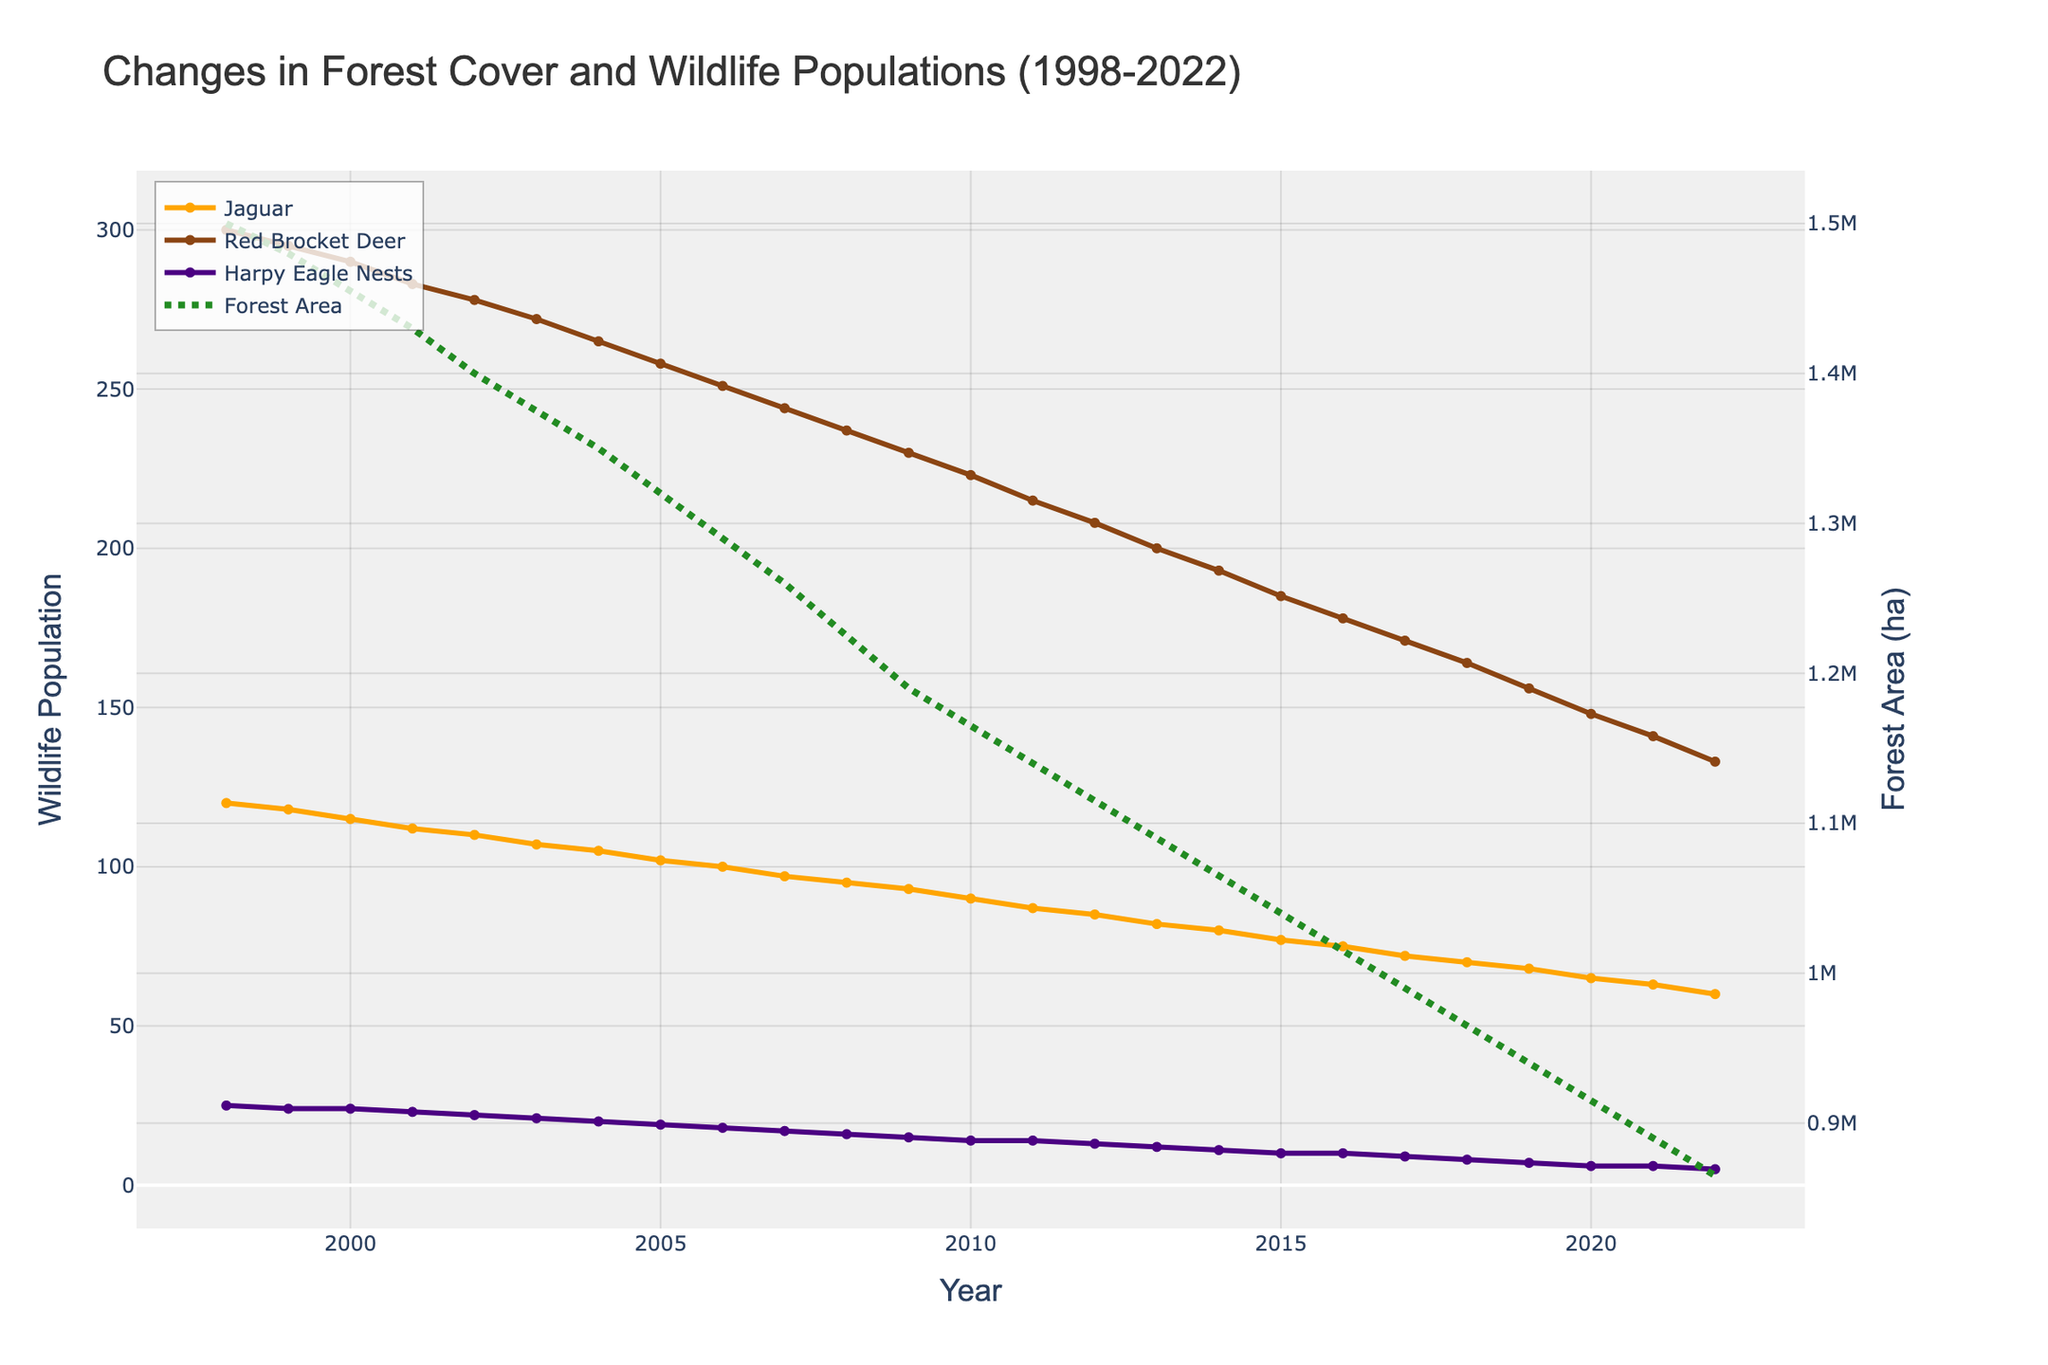What is the title of the figure? The title of the figure is typically placed at the top of the chart and is meant to describe the content of the visual representation. The title in this case is prominently displayed and reads "Changes in Forest Cover and Wildlife Populations (1998-2022)."
Answer: Changes in Forest Cover and Wildlife Populations (1998-2022) How has the Jaguar population changed over the 25-year period? To answer this, you need to look at the line representing Jaguar Population on the plot. The line starts near 120 in 1998 and shows a decline over time, ending at 60 in 2022. This indicates the population has halved over this period.
Answer: Decreased from 120 to 60 Which wildlife population saw the sharpest decline? By examining the slopes of the lines representing each wildlife population, the Jaguar population line shows the steepest slope indicating the sharpest decline when compared to Red Brocket Deer and Harpy Eagle Nests.
Answer: Jaguar Population What was the forest area in hectares in the year 2010? To answer this, find the point on the Forest Area line (dotted line) corresponding to the year 2010. The value at this point will be read off the right y-axis. The forest area in 2010 is approximately 1,165,000 hectares.
Answer: 1,165,000 hectares Between which two years did the Jaguar population experience the largest decline? To determine this, examine the slopes of the Jaguar Population line segments between each pair of consecutive years. The largest decline in Jaguar population appears between 1998 and 1999.
Answer: Between 1998 and 1999 Does the Harpy Eagle Nest Sightings appear to have a direct relationship with forest area? By visually comparing the trend of Harpy Eagle Nest Sightings with the trend of Forest Area over the years, it is noticeable that as the forest area decreases, Harpy Eagle Nest Sightings also decrease. This suggests a potential direct relationship.
Answer: Yes, it has a direct relationship How has the Red Brocket Deer population changed from the year 2000 to 2010? Locate both years on the x-axis and look at the Red Brocket Deer line values. In 2000, the population was 290, and in 2010, it was 223, hence the population decreased by 67.
Answer: Decreased by 67 (from 290 to 223) What is the trend in forest area over the 25 years? By following the dotted Forest Area line across the x-axis from 1998 to 2022, it is clear that the forest area has been consistently declining.
Answer: Consistently declining Which year saw equal values for Jaguar Population and Red Brocket Deer Population on the left y-axis scale? Carefully examine the plot to see if, at any point, the lines for Jaguar Population and Red Brocket Deer Population intersect. However, there's no year in which these two populations have equal values throughout the provided time frame.
Answer: No year shows equal values 